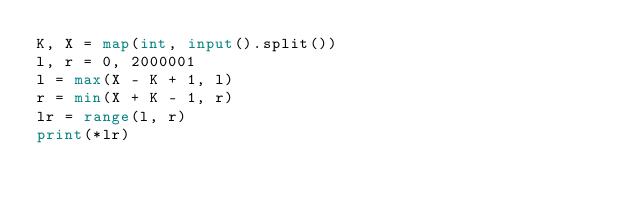Convert code to text. <code><loc_0><loc_0><loc_500><loc_500><_Python_>K, X = map(int, input().split())
l, r = 0, 2000001
l = max(X - K + 1, l)
r = min(X + K - 1, r)
lr = range(l, r)
print(*lr)</code> 